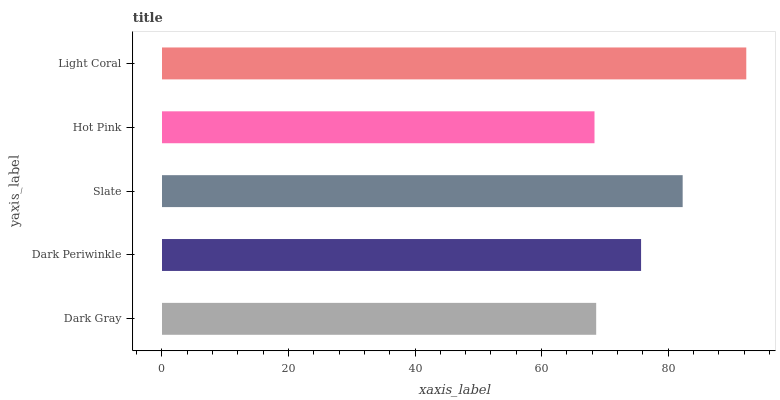Is Hot Pink the minimum?
Answer yes or no. Yes. Is Light Coral the maximum?
Answer yes or no. Yes. Is Dark Periwinkle the minimum?
Answer yes or no. No. Is Dark Periwinkle the maximum?
Answer yes or no. No. Is Dark Periwinkle greater than Dark Gray?
Answer yes or no. Yes. Is Dark Gray less than Dark Periwinkle?
Answer yes or no. Yes. Is Dark Gray greater than Dark Periwinkle?
Answer yes or no. No. Is Dark Periwinkle less than Dark Gray?
Answer yes or no. No. Is Dark Periwinkle the high median?
Answer yes or no. Yes. Is Dark Periwinkle the low median?
Answer yes or no. Yes. Is Light Coral the high median?
Answer yes or no. No. Is Hot Pink the low median?
Answer yes or no. No. 